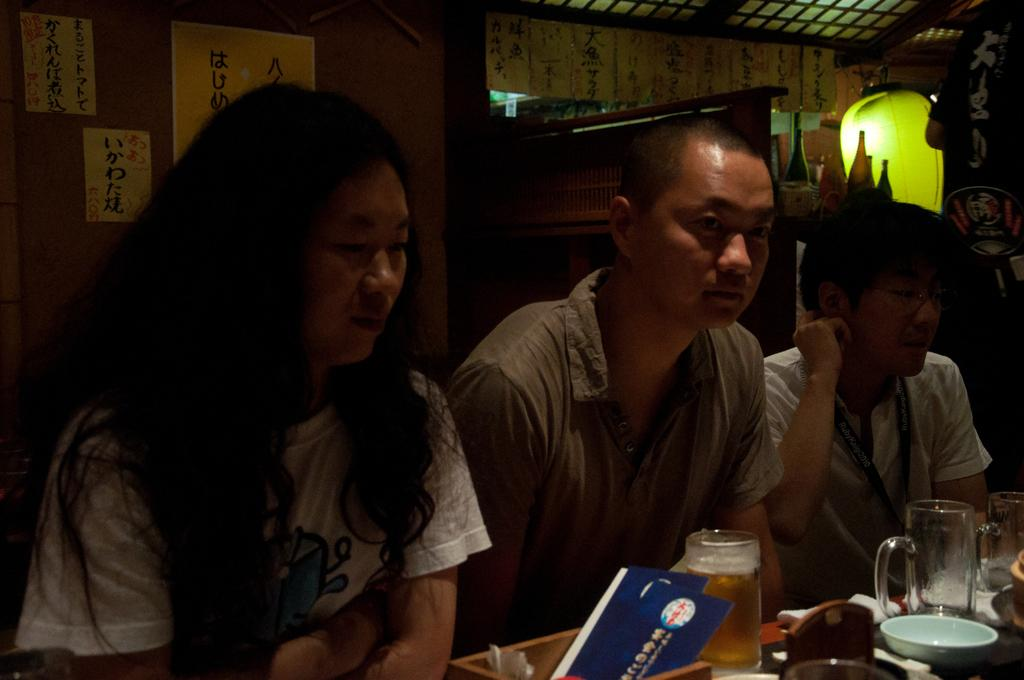What are the people in the image doing? The people in the image are sitting on chairs. What is present on the table in the image? There is a wine glass and a bowl on the table in the image. Can you describe the table in the image? The table is a piece of furniture where the wine glass and bowl are placed. What game are the people playing in the image? There is no game being played in the image; the people are simply sitting on chairs. 